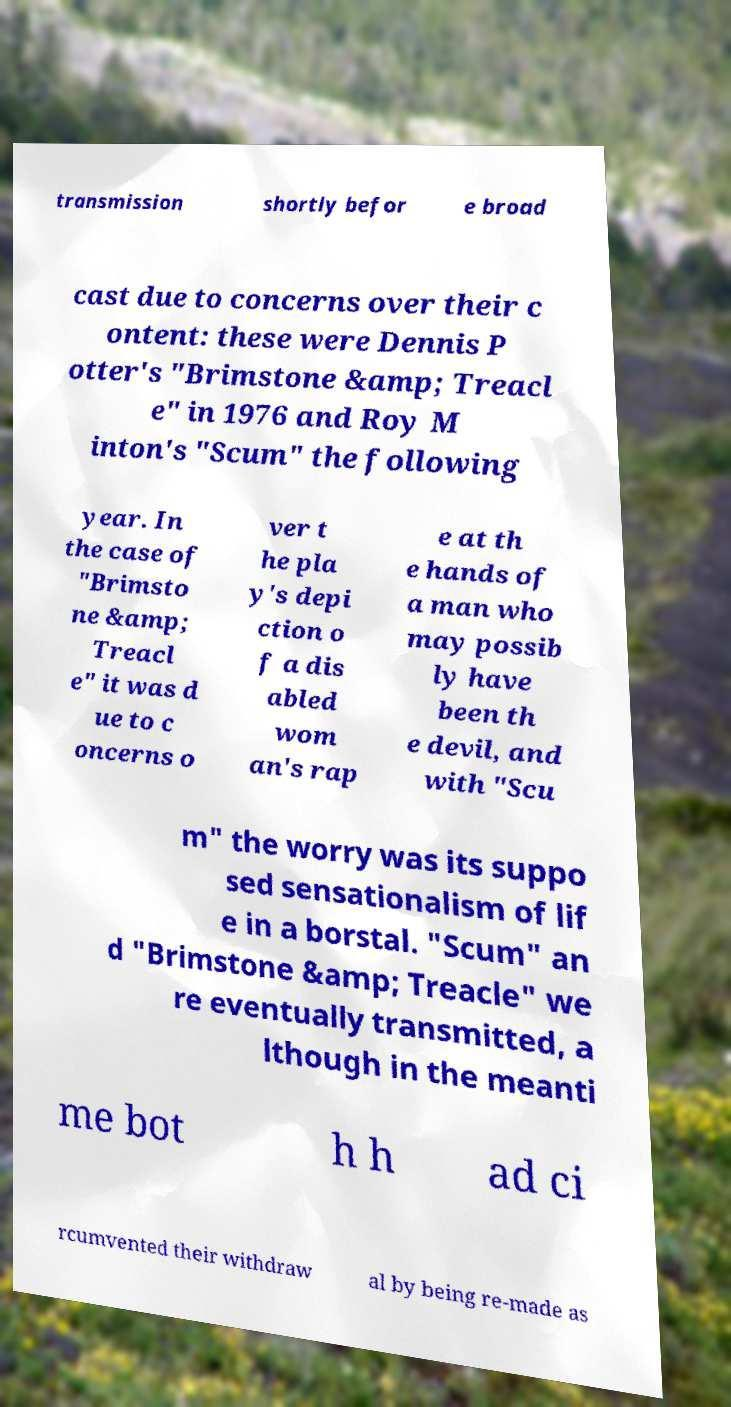Can you accurately transcribe the text from the provided image for me? transmission shortly befor e broad cast due to concerns over their c ontent: these were Dennis P otter's "Brimstone &amp; Treacl e" in 1976 and Roy M inton's "Scum" the following year. In the case of "Brimsto ne &amp; Treacl e" it was d ue to c oncerns o ver t he pla y's depi ction o f a dis abled wom an's rap e at th e hands of a man who may possib ly have been th e devil, and with "Scu m" the worry was its suppo sed sensationalism of lif e in a borstal. "Scum" an d "Brimstone &amp; Treacle" we re eventually transmitted, a lthough in the meanti me bot h h ad ci rcumvented their withdraw al by being re-made as 